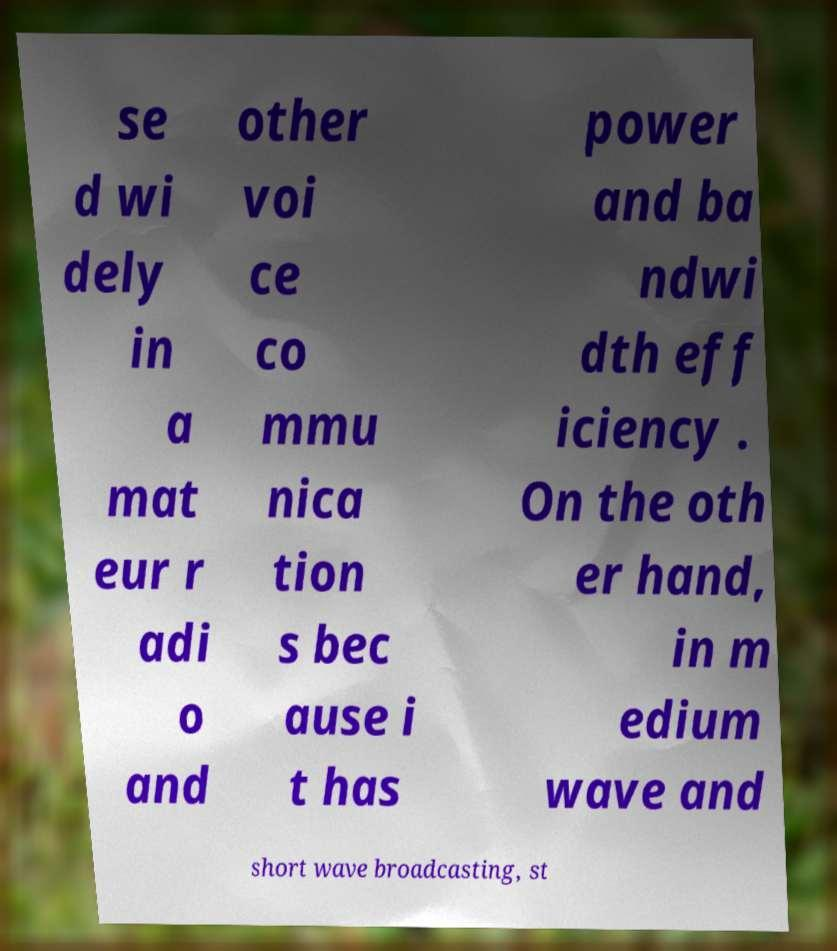Please identify and transcribe the text found in this image. se d wi dely in a mat eur r adi o and other voi ce co mmu nica tion s bec ause i t has power and ba ndwi dth eff iciency . On the oth er hand, in m edium wave and short wave broadcasting, st 